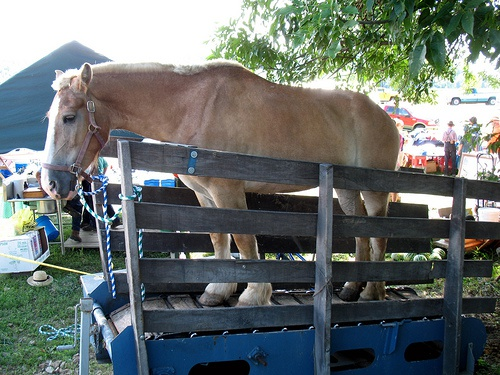Describe the objects in this image and their specific colors. I can see truck in white, black, gray, navy, and blue tones, horse in white, gray, darkgray, and maroon tones, people in white, darkgray, lightpink, and gray tones, car in white, salmon, lightpink, and gray tones, and truck in white, salmon, lightpink, and darkgray tones in this image. 